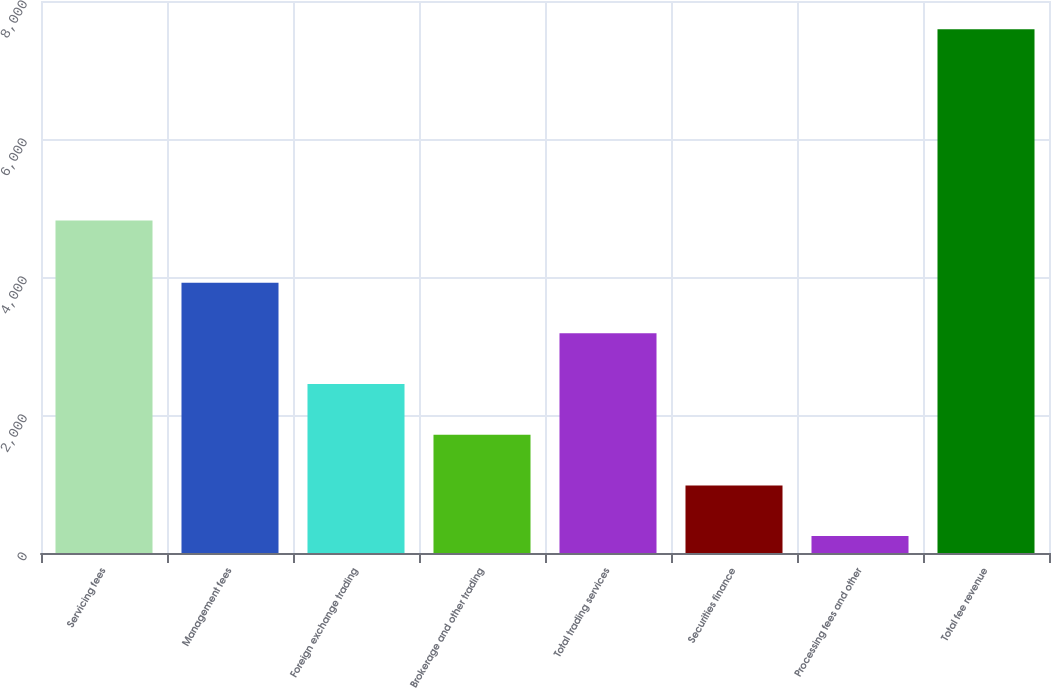Convert chart to OTSL. <chart><loc_0><loc_0><loc_500><loc_500><bar_chart><fcel>Servicing fees<fcel>Management fees<fcel>Foreign exchange trading<fcel>Brokerage and other trading<fcel>Total trading services<fcel>Securities finance<fcel>Processing fees and other<fcel>Total fee revenue<nl><fcel>4819<fcel>3917.5<fcel>2448.5<fcel>1714<fcel>3183<fcel>979.5<fcel>245<fcel>7590<nl></chart> 